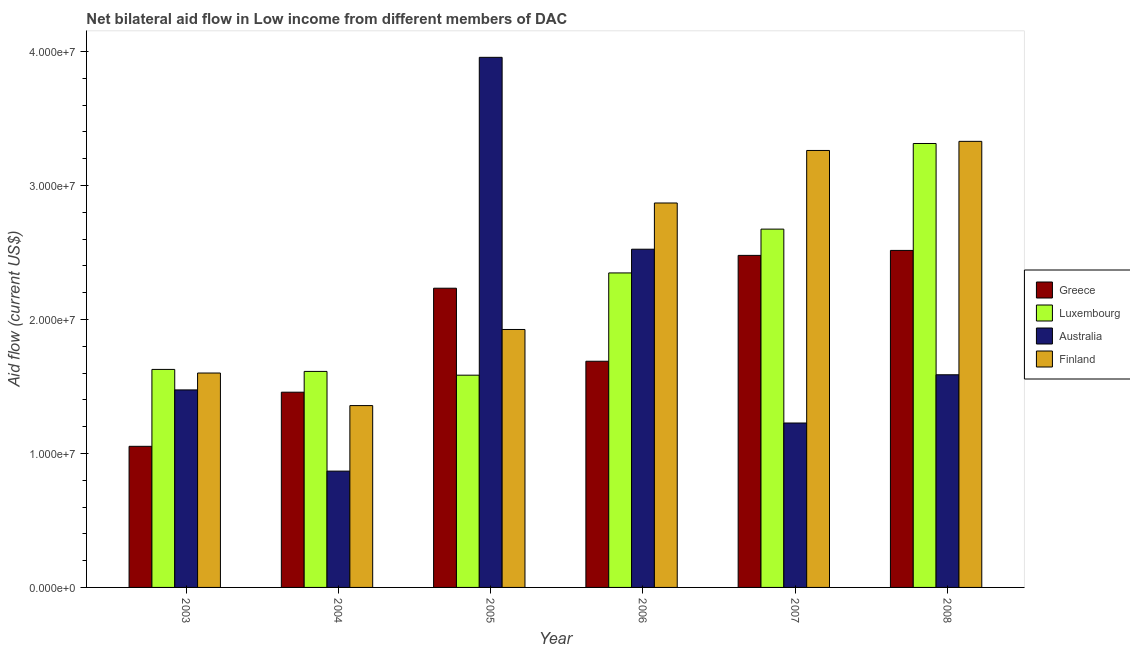How many different coloured bars are there?
Ensure brevity in your answer.  4. Are the number of bars on each tick of the X-axis equal?
Your answer should be compact. Yes. How many bars are there on the 6th tick from the right?
Your response must be concise. 4. What is the label of the 5th group of bars from the left?
Provide a succinct answer. 2007. What is the amount of aid given by finland in 2005?
Provide a short and direct response. 1.92e+07. Across all years, what is the maximum amount of aid given by australia?
Your response must be concise. 3.96e+07. Across all years, what is the minimum amount of aid given by australia?
Offer a very short reply. 8.68e+06. What is the total amount of aid given by greece in the graph?
Ensure brevity in your answer.  1.14e+08. What is the difference between the amount of aid given by greece in 2006 and that in 2008?
Ensure brevity in your answer.  -8.27e+06. What is the difference between the amount of aid given by finland in 2005 and the amount of aid given by greece in 2006?
Offer a terse response. -9.44e+06. What is the average amount of aid given by finland per year?
Provide a short and direct response. 2.39e+07. In the year 2006, what is the difference between the amount of aid given by greece and amount of aid given by luxembourg?
Provide a short and direct response. 0. In how many years, is the amount of aid given by finland greater than 16000000 US$?
Offer a terse response. 4. What is the ratio of the amount of aid given by greece in 2005 to that in 2008?
Keep it short and to the point. 0.89. Is the amount of aid given by greece in 2004 less than that in 2008?
Give a very brief answer. Yes. What is the difference between the highest and the second highest amount of aid given by australia?
Keep it short and to the point. 1.43e+07. What is the difference between the highest and the lowest amount of aid given by finland?
Your answer should be very brief. 1.97e+07. Is it the case that in every year, the sum of the amount of aid given by finland and amount of aid given by greece is greater than the sum of amount of aid given by luxembourg and amount of aid given by australia?
Make the answer very short. No. What does the 2nd bar from the left in 2005 represents?
Make the answer very short. Luxembourg. What does the 2nd bar from the right in 2006 represents?
Keep it short and to the point. Australia. Are all the bars in the graph horizontal?
Provide a short and direct response. No. Are the values on the major ticks of Y-axis written in scientific E-notation?
Ensure brevity in your answer.  Yes. Where does the legend appear in the graph?
Keep it short and to the point. Center right. How many legend labels are there?
Give a very brief answer. 4. What is the title of the graph?
Offer a terse response. Net bilateral aid flow in Low income from different members of DAC. What is the label or title of the X-axis?
Keep it short and to the point. Year. What is the label or title of the Y-axis?
Provide a short and direct response. Aid flow (current US$). What is the Aid flow (current US$) of Greece in 2003?
Keep it short and to the point. 1.05e+07. What is the Aid flow (current US$) of Luxembourg in 2003?
Provide a succinct answer. 1.63e+07. What is the Aid flow (current US$) in Australia in 2003?
Offer a terse response. 1.47e+07. What is the Aid flow (current US$) in Finland in 2003?
Make the answer very short. 1.60e+07. What is the Aid flow (current US$) in Greece in 2004?
Offer a terse response. 1.46e+07. What is the Aid flow (current US$) of Luxembourg in 2004?
Offer a very short reply. 1.61e+07. What is the Aid flow (current US$) in Australia in 2004?
Your response must be concise. 8.68e+06. What is the Aid flow (current US$) of Finland in 2004?
Provide a succinct answer. 1.36e+07. What is the Aid flow (current US$) of Greece in 2005?
Your answer should be very brief. 2.23e+07. What is the Aid flow (current US$) in Luxembourg in 2005?
Your answer should be compact. 1.58e+07. What is the Aid flow (current US$) in Australia in 2005?
Provide a succinct answer. 3.96e+07. What is the Aid flow (current US$) of Finland in 2005?
Give a very brief answer. 1.92e+07. What is the Aid flow (current US$) of Greece in 2006?
Your answer should be compact. 1.69e+07. What is the Aid flow (current US$) in Luxembourg in 2006?
Your answer should be very brief. 2.35e+07. What is the Aid flow (current US$) in Australia in 2006?
Provide a short and direct response. 2.52e+07. What is the Aid flow (current US$) of Finland in 2006?
Offer a terse response. 2.87e+07. What is the Aid flow (current US$) in Greece in 2007?
Ensure brevity in your answer.  2.48e+07. What is the Aid flow (current US$) in Luxembourg in 2007?
Give a very brief answer. 2.67e+07. What is the Aid flow (current US$) in Australia in 2007?
Make the answer very short. 1.23e+07. What is the Aid flow (current US$) in Finland in 2007?
Your answer should be very brief. 3.26e+07. What is the Aid flow (current US$) of Greece in 2008?
Offer a very short reply. 2.52e+07. What is the Aid flow (current US$) in Luxembourg in 2008?
Your answer should be compact. 3.31e+07. What is the Aid flow (current US$) of Australia in 2008?
Offer a terse response. 1.59e+07. What is the Aid flow (current US$) in Finland in 2008?
Offer a terse response. 3.33e+07. Across all years, what is the maximum Aid flow (current US$) of Greece?
Your response must be concise. 2.52e+07. Across all years, what is the maximum Aid flow (current US$) of Luxembourg?
Provide a succinct answer. 3.31e+07. Across all years, what is the maximum Aid flow (current US$) in Australia?
Provide a succinct answer. 3.96e+07. Across all years, what is the maximum Aid flow (current US$) of Finland?
Give a very brief answer. 3.33e+07. Across all years, what is the minimum Aid flow (current US$) of Greece?
Your answer should be very brief. 1.05e+07. Across all years, what is the minimum Aid flow (current US$) of Luxembourg?
Give a very brief answer. 1.58e+07. Across all years, what is the minimum Aid flow (current US$) of Australia?
Offer a terse response. 8.68e+06. Across all years, what is the minimum Aid flow (current US$) of Finland?
Keep it short and to the point. 1.36e+07. What is the total Aid flow (current US$) in Greece in the graph?
Provide a succinct answer. 1.14e+08. What is the total Aid flow (current US$) in Luxembourg in the graph?
Your response must be concise. 1.32e+08. What is the total Aid flow (current US$) in Australia in the graph?
Offer a very short reply. 1.16e+08. What is the total Aid flow (current US$) of Finland in the graph?
Your answer should be very brief. 1.43e+08. What is the difference between the Aid flow (current US$) of Greece in 2003 and that in 2004?
Provide a short and direct response. -4.04e+06. What is the difference between the Aid flow (current US$) in Australia in 2003 and that in 2004?
Ensure brevity in your answer.  6.06e+06. What is the difference between the Aid flow (current US$) of Finland in 2003 and that in 2004?
Provide a succinct answer. 2.43e+06. What is the difference between the Aid flow (current US$) of Greece in 2003 and that in 2005?
Provide a short and direct response. -1.18e+07. What is the difference between the Aid flow (current US$) in Luxembourg in 2003 and that in 2005?
Your answer should be compact. 4.30e+05. What is the difference between the Aid flow (current US$) of Australia in 2003 and that in 2005?
Your response must be concise. -2.48e+07. What is the difference between the Aid flow (current US$) of Finland in 2003 and that in 2005?
Offer a terse response. -3.25e+06. What is the difference between the Aid flow (current US$) of Greece in 2003 and that in 2006?
Offer a very short reply. -6.35e+06. What is the difference between the Aid flow (current US$) of Luxembourg in 2003 and that in 2006?
Keep it short and to the point. -7.20e+06. What is the difference between the Aid flow (current US$) of Australia in 2003 and that in 2006?
Keep it short and to the point. -1.05e+07. What is the difference between the Aid flow (current US$) of Finland in 2003 and that in 2006?
Ensure brevity in your answer.  -1.27e+07. What is the difference between the Aid flow (current US$) in Greece in 2003 and that in 2007?
Keep it short and to the point. -1.42e+07. What is the difference between the Aid flow (current US$) in Luxembourg in 2003 and that in 2007?
Make the answer very short. -1.05e+07. What is the difference between the Aid flow (current US$) in Australia in 2003 and that in 2007?
Make the answer very short. 2.47e+06. What is the difference between the Aid flow (current US$) of Finland in 2003 and that in 2007?
Your answer should be compact. -1.66e+07. What is the difference between the Aid flow (current US$) in Greece in 2003 and that in 2008?
Provide a short and direct response. -1.46e+07. What is the difference between the Aid flow (current US$) in Luxembourg in 2003 and that in 2008?
Give a very brief answer. -1.69e+07. What is the difference between the Aid flow (current US$) in Australia in 2003 and that in 2008?
Give a very brief answer. -1.13e+06. What is the difference between the Aid flow (current US$) in Finland in 2003 and that in 2008?
Provide a short and direct response. -1.73e+07. What is the difference between the Aid flow (current US$) in Greece in 2004 and that in 2005?
Your response must be concise. -7.76e+06. What is the difference between the Aid flow (current US$) of Australia in 2004 and that in 2005?
Provide a succinct answer. -3.09e+07. What is the difference between the Aid flow (current US$) of Finland in 2004 and that in 2005?
Make the answer very short. -5.68e+06. What is the difference between the Aid flow (current US$) in Greece in 2004 and that in 2006?
Keep it short and to the point. -2.31e+06. What is the difference between the Aid flow (current US$) of Luxembourg in 2004 and that in 2006?
Your response must be concise. -7.35e+06. What is the difference between the Aid flow (current US$) in Australia in 2004 and that in 2006?
Ensure brevity in your answer.  -1.66e+07. What is the difference between the Aid flow (current US$) of Finland in 2004 and that in 2006?
Your answer should be compact. -1.51e+07. What is the difference between the Aid flow (current US$) in Greece in 2004 and that in 2007?
Provide a succinct answer. -1.02e+07. What is the difference between the Aid flow (current US$) in Luxembourg in 2004 and that in 2007?
Give a very brief answer. -1.06e+07. What is the difference between the Aid flow (current US$) of Australia in 2004 and that in 2007?
Keep it short and to the point. -3.59e+06. What is the difference between the Aid flow (current US$) in Finland in 2004 and that in 2007?
Ensure brevity in your answer.  -1.90e+07. What is the difference between the Aid flow (current US$) in Greece in 2004 and that in 2008?
Provide a short and direct response. -1.06e+07. What is the difference between the Aid flow (current US$) in Luxembourg in 2004 and that in 2008?
Provide a succinct answer. -1.70e+07. What is the difference between the Aid flow (current US$) of Australia in 2004 and that in 2008?
Ensure brevity in your answer.  -7.19e+06. What is the difference between the Aid flow (current US$) in Finland in 2004 and that in 2008?
Offer a terse response. -1.97e+07. What is the difference between the Aid flow (current US$) in Greece in 2005 and that in 2006?
Keep it short and to the point. 5.45e+06. What is the difference between the Aid flow (current US$) of Luxembourg in 2005 and that in 2006?
Your answer should be very brief. -7.63e+06. What is the difference between the Aid flow (current US$) in Australia in 2005 and that in 2006?
Ensure brevity in your answer.  1.43e+07. What is the difference between the Aid flow (current US$) of Finland in 2005 and that in 2006?
Keep it short and to the point. -9.44e+06. What is the difference between the Aid flow (current US$) in Greece in 2005 and that in 2007?
Your answer should be compact. -2.45e+06. What is the difference between the Aid flow (current US$) of Luxembourg in 2005 and that in 2007?
Provide a short and direct response. -1.09e+07. What is the difference between the Aid flow (current US$) of Australia in 2005 and that in 2007?
Your answer should be compact. 2.73e+07. What is the difference between the Aid flow (current US$) in Finland in 2005 and that in 2007?
Your response must be concise. -1.34e+07. What is the difference between the Aid flow (current US$) in Greece in 2005 and that in 2008?
Your answer should be compact. -2.82e+06. What is the difference between the Aid flow (current US$) of Luxembourg in 2005 and that in 2008?
Offer a terse response. -1.73e+07. What is the difference between the Aid flow (current US$) in Australia in 2005 and that in 2008?
Keep it short and to the point. 2.37e+07. What is the difference between the Aid flow (current US$) in Finland in 2005 and that in 2008?
Keep it short and to the point. -1.40e+07. What is the difference between the Aid flow (current US$) in Greece in 2006 and that in 2007?
Provide a short and direct response. -7.90e+06. What is the difference between the Aid flow (current US$) of Luxembourg in 2006 and that in 2007?
Provide a short and direct response. -3.27e+06. What is the difference between the Aid flow (current US$) in Australia in 2006 and that in 2007?
Provide a succinct answer. 1.30e+07. What is the difference between the Aid flow (current US$) of Finland in 2006 and that in 2007?
Offer a terse response. -3.92e+06. What is the difference between the Aid flow (current US$) of Greece in 2006 and that in 2008?
Your answer should be very brief. -8.27e+06. What is the difference between the Aid flow (current US$) in Luxembourg in 2006 and that in 2008?
Your answer should be compact. -9.66e+06. What is the difference between the Aid flow (current US$) in Australia in 2006 and that in 2008?
Your response must be concise. 9.37e+06. What is the difference between the Aid flow (current US$) in Finland in 2006 and that in 2008?
Your answer should be compact. -4.60e+06. What is the difference between the Aid flow (current US$) of Greece in 2007 and that in 2008?
Provide a succinct answer. -3.70e+05. What is the difference between the Aid flow (current US$) of Luxembourg in 2007 and that in 2008?
Give a very brief answer. -6.39e+06. What is the difference between the Aid flow (current US$) of Australia in 2007 and that in 2008?
Keep it short and to the point. -3.60e+06. What is the difference between the Aid flow (current US$) in Finland in 2007 and that in 2008?
Your answer should be very brief. -6.80e+05. What is the difference between the Aid flow (current US$) of Greece in 2003 and the Aid flow (current US$) of Luxembourg in 2004?
Your answer should be very brief. -5.59e+06. What is the difference between the Aid flow (current US$) in Greece in 2003 and the Aid flow (current US$) in Australia in 2004?
Make the answer very short. 1.85e+06. What is the difference between the Aid flow (current US$) in Greece in 2003 and the Aid flow (current US$) in Finland in 2004?
Give a very brief answer. -3.04e+06. What is the difference between the Aid flow (current US$) of Luxembourg in 2003 and the Aid flow (current US$) of Australia in 2004?
Make the answer very short. 7.59e+06. What is the difference between the Aid flow (current US$) in Luxembourg in 2003 and the Aid flow (current US$) in Finland in 2004?
Provide a short and direct response. 2.70e+06. What is the difference between the Aid flow (current US$) in Australia in 2003 and the Aid flow (current US$) in Finland in 2004?
Offer a very short reply. 1.17e+06. What is the difference between the Aid flow (current US$) in Greece in 2003 and the Aid flow (current US$) in Luxembourg in 2005?
Offer a very short reply. -5.31e+06. What is the difference between the Aid flow (current US$) of Greece in 2003 and the Aid flow (current US$) of Australia in 2005?
Give a very brief answer. -2.90e+07. What is the difference between the Aid flow (current US$) of Greece in 2003 and the Aid flow (current US$) of Finland in 2005?
Your answer should be very brief. -8.72e+06. What is the difference between the Aid flow (current US$) in Luxembourg in 2003 and the Aid flow (current US$) in Australia in 2005?
Your response must be concise. -2.33e+07. What is the difference between the Aid flow (current US$) of Luxembourg in 2003 and the Aid flow (current US$) of Finland in 2005?
Give a very brief answer. -2.98e+06. What is the difference between the Aid flow (current US$) of Australia in 2003 and the Aid flow (current US$) of Finland in 2005?
Offer a very short reply. -4.51e+06. What is the difference between the Aid flow (current US$) in Greece in 2003 and the Aid flow (current US$) in Luxembourg in 2006?
Offer a terse response. -1.29e+07. What is the difference between the Aid flow (current US$) of Greece in 2003 and the Aid flow (current US$) of Australia in 2006?
Provide a short and direct response. -1.47e+07. What is the difference between the Aid flow (current US$) of Greece in 2003 and the Aid flow (current US$) of Finland in 2006?
Your response must be concise. -1.82e+07. What is the difference between the Aid flow (current US$) of Luxembourg in 2003 and the Aid flow (current US$) of Australia in 2006?
Keep it short and to the point. -8.97e+06. What is the difference between the Aid flow (current US$) in Luxembourg in 2003 and the Aid flow (current US$) in Finland in 2006?
Your answer should be compact. -1.24e+07. What is the difference between the Aid flow (current US$) of Australia in 2003 and the Aid flow (current US$) of Finland in 2006?
Provide a short and direct response. -1.40e+07. What is the difference between the Aid flow (current US$) in Greece in 2003 and the Aid flow (current US$) in Luxembourg in 2007?
Provide a succinct answer. -1.62e+07. What is the difference between the Aid flow (current US$) of Greece in 2003 and the Aid flow (current US$) of Australia in 2007?
Offer a terse response. -1.74e+06. What is the difference between the Aid flow (current US$) in Greece in 2003 and the Aid flow (current US$) in Finland in 2007?
Keep it short and to the point. -2.21e+07. What is the difference between the Aid flow (current US$) in Luxembourg in 2003 and the Aid flow (current US$) in Australia in 2007?
Keep it short and to the point. 4.00e+06. What is the difference between the Aid flow (current US$) in Luxembourg in 2003 and the Aid flow (current US$) in Finland in 2007?
Make the answer very short. -1.63e+07. What is the difference between the Aid flow (current US$) in Australia in 2003 and the Aid flow (current US$) in Finland in 2007?
Offer a very short reply. -1.79e+07. What is the difference between the Aid flow (current US$) in Greece in 2003 and the Aid flow (current US$) in Luxembourg in 2008?
Keep it short and to the point. -2.26e+07. What is the difference between the Aid flow (current US$) of Greece in 2003 and the Aid flow (current US$) of Australia in 2008?
Make the answer very short. -5.34e+06. What is the difference between the Aid flow (current US$) in Greece in 2003 and the Aid flow (current US$) in Finland in 2008?
Your answer should be compact. -2.28e+07. What is the difference between the Aid flow (current US$) in Luxembourg in 2003 and the Aid flow (current US$) in Finland in 2008?
Offer a terse response. -1.70e+07. What is the difference between the Aid flow (current US$) of Australia in 2003 and the Aid flow (current US$) of Finland in 2008?
Your answer should be compact. -1.86e+07. What is the difference between the Aid flow (current US$) of Greece in 2004 and the Aid flow (current US$) of Luxembourg in 2005?
Your answer should be very brief. -1.27e+06. What is the difference between the Aid flow (current US$) in Greece in 2004 and the Aid flow (current US$) in Australia in 2005?
Make the answer very short. -2.50e+07. What is the difference between the Aid flow (current US$) of Greece in 2004 and the Aid flow (current US$) of Finland in 2005?
Provide a succinct answer. -4.68e+06. What is the difference between the Aid flow (current US$) in Luxembourg in 2004 and the Aid flow (current US$) in Australia in 2005?
Ensure brevity in your answer.  -2.34e+07. What is the difference between the Aid flow (current US$) in Luxembourg in 2004 and the Aid flow (current US$) in Finland in 2005?
Offer a terse response. -3.13e+06. What is the difference between the Aid flow (current US$) in Australia in 2004 and the Aid flow (current US$) in Finland in 2005?
Provide a succinct answer. -1.06e+07. What is the difference between the Aid flow (current US$) in Greece in 2004 and the Aid flow (current US$) in Luxembourg in 2006?
Your answer should be compact. -8.90e+06. What is the difference between the Aid flow (current US$) of Greece in 2004 and the Aid flow (current US$) of Australia in 2006?
Make the answer very short. -1.07e+07. What is the difference between the Aid flow (current US$) of Greece in 2004 and the Aid flow (current US$) of Finland in 2006?
Your answer should be very brief. -1.41e+07. What is the difference between the Aid flow (current US$) of Luxembourg in 2004 and the Aid flow (current US$) of Australia in 2006?
Provide a short and direct response. -9.12e+06. What is the difference between the Aid flow (current US$) in Luxembourg in 2004 and the Aid flow (current US$) in Finland in 2006?
Make the answer very short. -1.26e+07. What is the difference between the Aid flow (current US$) in Australia in 2004 and the Aid flow (current US$) in Finland in 2006?
Your answer should be very brief. -2.00e+07. What is the difference between the Aid flow (current US$) of Greece in 2004 and the Aid flow (current US$) of Luxembourg in 2007?
Offer a terse response. -1.22e+07. What is the difference between the Aid flow (current US$) of Greece in 2004 and the Aid flow (current US$) of Australia in 2007?
Provide a short and direct response. 2.30e+06. What is the difference between the Aid flow (current US$) of Greece in 2004 and the Aid flow (current US$) of Finland in 2007?
Your response must be concise. -1.80e+07. What is the difference between the Aid flow (current US$) in Luxembourg in 2004 and the Aid flow (current US$) in Australia in 2007?
Offer a terse response. 3.85e+06. What is the difference between the Aid flow (current US$) of Luxembourg in 2004 and the Aid flow (current US$) of Finland in 2007?
Give a very brief answer. -1.65e+07. What is the difference between the Aid flow (current US$) in Australia in 2004 and the Aid flow (current US$) in Finland in 2007?
Your response must be concise. -2.39e+07. What is the difference between the Aid flow (current US$) in Greece in 2004 and the Aid flow (current US$) in Luxembourg in 2008?
Offer a very short reply. -1.86e+07. What is the difference between the Aid flow (current US$) in Greece in 2004 and the Aid flow (current US$) in Australia in 2008?
Your answer should be very brief. -1.30e+06. What is the difference between the Aid flow (current US$) of Greece in 2004 and the Aid flow (current US$) of Finland in 2008?
Your response must be concise. -1.87e+07. What is the difference between the Aid flow (current US$) in Luxembourg in 2004 and the Aid flow (current US$) in Australia in 2008?
Give a very brief answer. 2.50e+05. What is the difference between the Aid flow (current US$) of Luxembourg in 2004 and the Aid flow (current US$) of Finland in 2008?
Provide a succinct answer. -1.72e+07. What is the difference between the Aid flow (current US$) in Australia in 2004 and the Aid flow (current US$) in Finland in 2008?
Make the answer very short. -2.46e+07. What is the difference between the Aid flow (current US$) in Greece in 2005 and the Aid flow (current US$) in Luxembourg in 2006?
Make the answer very short. -1.14e+06. What is the difference between the Aid flow (current US$) in Greece in 2005 and the Aid flow (current US$) in Australia in 2006?
Offer a very short reply. -2.91e+06. What is the difference between the Aid flow (current US$) in Greece in 2005 and the Aid flow (current US$) in Finland in 2006?
Make the answer very short. -6.36e+06. What is the difference between the Aid flow (current US$) of Luxembourg in 2005 and the Aid flow (current US$) of Australia in 2006?
Give a very brief answer. -9.40e+06. What is the difference between the Aid flow (current US$) of Luxembourg in 2005 and the Aid flow (current US$) of Finland in 2006?
Ensure brevity in your answer.  -1.28e+07. What is the difference between the Aid flow (current US$) of Australia in 2005 and the Aid flow (current US$) of Finland in 2006?
Your answer should be compact. 1.09e+07. What is the difference between the Aid flow (current US$) of Greece in 2005 and the Aid flow (current US$) of Luxembourg in 2007?
Provide a short and direct response. -4.41e+06. What is the difference between the Aid flow (current US$) of Greece in 2005 and the Aid flow (current US$) of Australia in 2007?
Offer a terse response. 1.01e+07. What is the difference between the Aid flow (current US$) in Greece in 2005 and the Aid flow (current US$) in Finland in 2007?
Keep it short and to the point. -1.03e+07. What is the difference between the Aid flow (current US$) in Luxembourg in 2005 and the Aid flow (current US$) in Australia in 2007?
Your response must be concise. 3.57e+06. What is the difference between the Aid flow (current US$) of Luxembourg in 2005 and the Aid flow (current US$) of Finland in 2007?
Provide a succinct answer. -1.68e+07. What is the difference between the Aid flow (current US$) in Australia in 2005 and the Aid flow (current US$) in Finland in 2007?
Ensure brevity in your answer.  6.95e+06. What is the difference between the Aid flow (current US$) of Greece in 2005 and the Aid flow (current US$) of Luxembourg in 2008?
Keep it short and to the point. -1.08e+07. What is the difference between the Aid flow (current US$) of Greece in 2005 and the Aid flow (current US$) of Australia in 2008?
Ensure brevity in your answer.  6.46e+06. What is the difference between the Aid flow (current US$) in Greece in 2005 and the Aid flow (current US$) in Finland in 2008?
Your answer should be very brief. -1.10e+07. What is the difference between the Aid flow (current US$) of Luxembourg in 2005 and the Aid flow (current US$) of Finland in 2008?
Provide a succinct answer. -1.74e+07. What is the difference between the Aid flow (current US$) of Australia in 2005 and the Aid flow (current US$) of Finland in 2008?
Ensure brevity in your answer.  6.27e+06. What is the difference between the Aid flow (current US$) of Greece in 2006 and the Aid flow (current US$) of Luxembourg in 2007?
Offer a very short reply. -9.86e+06. What is the difference between the Aid flow (current US$) in Greece in 2006 and the Aid flow (current US$) in Australia in 2007?
Your answer should be compact. 4.61e+06. What is the difference between the Aid flow (current US$) of Greece in 2006 and the Aid flow (current US$) of Finland in 2007?
Your answer should be compact. -1.57e+07. What is the difference between the Aid flow (current US$) of Luxembourg in 2006 and the Aid flow (current US$) of Australia in 2007?
Ensure brevity in your answer.  1.12e+07. What is the difference between the Aid flow (current US$) of Luxembourg in 2006 and the Aid flow (current US$) of Finland in 2007?
Your answer should be compact. -9.14e+06. What is the difference between the Aid flow (current US$) in Australia in 2006 and the Aid flow (current US$) in Finland in 2007?
Ensure brevity in your answer.  -7.37e+06. What is the difference between the Aid flow (current US$) of Greece in 2006 and the Aid flow (current US$) of Luxembourg in 2008?
Offer a terse response. -1.62e+07. What is the difference between the Aid flow (current US$) in Greece in 2006 and the Aid flow (current US$) in Australia in 2008?
Provide a short and direct response. 1.01e+06. What is the difference between the Aid flow (current US$) in Greece in 2006 and the Aid flow (current US$) in Finland in 2008?
Offer a very short reply. -1.64e+07. What is the difference between the Aid flow (current US$) of Luxembourg in 2006 and the Aid flow (current US$) of Australia in 2008?
Provide a short and direct response. 7.60e+06. What is the difference between the Aid flow (current US$) in Luxembourg in 2006 and the Aid flow (current US$) in Finland in 2008?
Give a very brief answer. -9.82e+06. What is the difference between the Aid flow (current US$) in Australia in 2006 and the Aid flow (current US$) in Finland in 2008?
Make the answer very short. -8.05e+06. What is the difference between the Aid flow (current US$) of Greece in 2007 and the Aid flow (current US$) of Luxembourg in 2008?
Your response must be concise. -8.35e+06. What is the difference between the Aid flow (current US$) in Greece in 2007 and the Aid flow (current US$) in Australia in 2008?
Provide a succinct answer. 8.91e+06. What is the difference between the Aid flow (current US$) in Greece in 2007 and the Aid flow (current US$) in Finland in 2008?
Offer a terse response. -8.51e+06. What is the difference between the Aid flow (current US$) of Luxembourg in 2007 and the Aid flow (current US$) of Australia in 2008?
Your answer should be compact. 1.09e+07. What is the difference between the Aid flow (current US$) in Luxembourg in 2007 and the Aid flow (current US$) in Finland in 2008?
Make the answer very short. -6.55e+06. What is the difference between the Aid flow (current US$) in Australia in 2007 and the Aid flow (current US$) in Finland in 2008?
Ensure brevity in your answer.  -2.10e+07. What is the average Aid flow (current US$) of Greece per year?
Offer a very short reply. 1.90e+07. What is the average Aid flow (current US$) of Luxembourg per year?
Ensure brevity in your answer.  2.19e+07. What is the average Aid flow (current US$) of Australia per year?
Offer a terse response. 1.94e+07. What is the average Aid flow (current US$) in Finland per year?
Keep it short and to the point. 2.39e+07. In the year 2003, what is the difference between the Aid flow (current US$) in Greece and Aid flow (current US$) in Luxembourg?
Keep it short and to the point. -5.74e+06. In the year 2003, what is the difference between the Aid flow (current US$) of Greece and Aid flow (current US$) of Australia?
Offer a very short reply. -4.21e+06. In the year 2003, what is the difference between the Aid flow (current US$) of Greece and Aid flow (current US$) of Finland?
Provide a succinct answer. -5.47e+06. In the year 2003, what is the difference between the Aid flow (current US$) of Luxembourg and Aid flow (current US$) of Australia?
Your response must be concise. 1.53e+06. In the year 2003, what is the difference between the Aid flow (current US$) of Australia and Aid flow (current US$) of Finland?
Your response must be concise. -1.26e+06. In the year 2004, what is the difference between the Aid flow (current US$) in Greece and Aid flow (current US$) in Luxembourg?
Make the answer very short. -1.55e+06. In the year 2004, what is the difference between the Aid flow (current US$) of Greece and Aid flow (current US$) of Australia?
Provide a succinct answer. 5.89e+06. In the year 2004, what is the difference between the Aid flow (current US$) of Luxembourg and Aid flow (current US$) of Australia?
Give a very brief answer. 7.44e+06. In the year 2004, what is the difference between the Aid flow (current US$) of Luxembourg and Aid flow (current US$) of Finland?
Provide a short and direct response. 2.55e+06. In the year 2004, what is the difference between the Aid flow (current US$) in Australia and Aid flow (current US$) in Finland?
Your response must be concise. -4.89e+06. In the year 2005, what is the difference between the Aid flow (current US$) in Greece and Aid flow (current US$) in Luxembourg?
Ensure brevity in your answer.  6.49e+06. In the year 2005, what is the difference between the Aid flow (current US$) of Greece and Aid flow (current US$) of Australia?
Your answer should be very brief. -1.72e+07. In the year 2005, what is the difference between the Aid flow (current US$) in Greece and Aid flow (current US$) in Finland?
Provide a short and direct response. 3.08e+06. In the year 2005, what is the difference between the Aid flow (current US$) of Luxembourg and Aid flow (current US$) of Australia?
Keep it short and to the point. -2.37e+07. In the year 2005, what is the difference between the Aid flow (current US$) of Luxembourg and Aid flow (current US$) of Finland?
Provide a short and direct response. -3.41e+06. In the year 2005, what is the difference between the Aid flow (current US$) in Australia and Aid flow (current US$) in Finland?
Make the answer very short. 2.03e+07. In the year 2006, what is the difference between the Aid flow (current US$) of Greece and Aid flow (current US$) of Luxembourg?
Keep it short and to the point. -6.59e+06. In the year 2006, what is the difference between the Aid flow (current US$) of Greece and Aid flow (current US$) of Australia?
Offer a terse response. -8.36e+06. In the year 2006, what is the difference between the Aid flow (current US$) in Greece and Aid flow (current US$) in Finland?
Keep it short and to the point. -1.18e+07. In the year 2006, what is the difference between the Aid flow (current US$) in Luxembourg and Aid flow (current US$) in Australia?
Keep it short and to the point. -1.77e+06. In the year 2006, what is the difference between the Aid flow (current US$) of Luxembourg and Aid flow (current US$) of Finland?
Ensure brevity in your answer.  -5.22e+06. In the year 2006, what is the difference between the Aid flow (current US$) of Australia and Aid flow (current US$) of Finland?
Your response must be concise. -3.45e+06. In the year 2007, what is the difference between the Aid flow (current US$) of Greece and Aid flow (current US$) of Luxembourg?
Your answer should be compact. -1.96e+06. In the year 2007, what is the difference between the Aid flow (current US$) of Greece and Aid flow (current US$) of Australia?
Offer a very short reply. 1.25e+07. In the year 2007, what is the difference between the Aid flow (current US$) in Greece and Aid flow (current US$) in Finland?
Provide a succinct answer. -7.83e+06. In the year 2007, what is the difference between the Aid flow (current US$) of Luxembourg and Aid flow (current US$) of Australia?
Your response must be concise. 1.45e+07. In the year 2007, what is the difference between the Aid flow (current US$) in Luxembourg and Aid flow (current US$) in Finland?
Your answer should be compact. -5.87e+06. In the year 2007, what is the difference between the Aid flow (current US$) in Australia and Aid flow (current US$) in Finland?
Your answer should be very brief. -2.03e+07. In the year 2008, what is the difference between the Aid flow (current US$) of Greece and Aid flow (current US$) of Luxembourg?
Make the answer very short. -7.98e+06. In the year 2008, what is the difference between the Aid flow (current US$) in Greece and Aid flow (current US$) in Australia?
Provide a succinct answer. 9.28e+06. In the year 2008, what is the difference between the Aid flow (current US$) of Greece and Aid flow (current US$) of Finland?
Keep it short and to the point. -8.14e+06. In the year 2008, what is the difference between the Aid flow (current US$) of Luxembourg and Aid flow (current US$) of Australia?
Provide a short and direct response. 1.73e+07. In the year 2008, what is the difference between the Aid flow (current US$) of Australia and Aid flow (current US$) of Finland?
Keep it short and to the point. -1.74e+07. What is the ratio of the Aid flow (current US$) in Greece in 2003 to that in 2004?
Your answer should be compact. 0.72. What is the ratio of the Aid flow (current US$) of Luxembourg in 2003 to that in 2004?
Provide a succinct answer. 1.01. What is the ratio of the Aid flow (current US$) of Australia in 2003 to that in 2004?
Your answer should be very brief. 1.7. What is the ratio of the Aid flow (current US$) in Finland in 2003 to that in 2004?
Your answer should be compact. 1.18. What is the ratio of the Aid flow (current US$) in Greece in 2003 to that in 2005?
Keep it short and to the point. 0.47. What is the ratio of the Aid flow (current US$) of Luxembourg in 2003 to that in 2005?
Keep it short and to the point. 1.03. What is the ratio of the Aid flow (current US$) of Australia in 2003 to that in 2005?
Your response must be concise. 0.37. What is the ratio of the Aid flow (current US$) in Finland in 2003 to that in 2005?
Ensure brevity in your answer.  0.83. What is the ratio of the Aid flow (current US$) in Greece in 2003 to that in 2006?
Ensure brevity in your answer.  0.62. What is the ratio of the Aid flow (current US$) in Luxembourg in 2003 to that in 2006?
Your response must be concise. 0.69. What is the ratio of the Aid flow (current US$) of Australia in 2003 to that in 2006?
Keep it short and to the point. 0.58. What is the ratio of the Aid flow (current US$) of Finland in 2003 to that in 2006?
Offer a terse response. 0.56. What is the ratio of the Aid flow (current US$) in Greece in 2003 to that in 2007?
Provide a short and direct response. 0.42. What is the ratio of the Aid flow (current US$) of Luxembourg in 2003 to that in 2007?
Make the answer very short. 0.61. What is the ratio of the Aid flow (current US$) in Australia in 2003 to that in 2007?
Your response must be concise. 1.2. What is the ratio of the Aid flow (current US$) of Finland in 2003 to that in 2007?
Your answer should be very brief. 0.49. What is the ratio of the Aid flow (current US$) in Greece in 2003 to that in 2008?
Give a very brief answer. 0.42. What is the ratio of the Aid flow (current US$) in Luxembourg in 2003 to that in 2008?
Make the answer very short. 0.49. What is the ratio of the Aid flow (current US$) of Australia in 2003 to that in 2008?
Offer a very short reply. 0.93. What is the ratio of the Aid flow (current US$) in Finland in 2003 to that in 2008?
Ensure brevity in your answer.  0.48. What is the ratio of the Aid flow (current US$) in Greece in 2004 to that in 2005?
Give a very brief answer. 0.65. What is the ratio of the Aid flow (current US$) in Luxembourg in 2004 to that in 2005?
Provide a succinct answer. 1.02. What is the ratio of the Aid flow (current US$) of Australia in 2004 to that in 2005?
Your answer should be very brief. 0.22. What is the ratio of the Aid flow (current US$) in Finland in 2004 to that in 2005?
Your response must be concise. 0.7. What is the ratio of the Aid flow (current US$) of Greece in 2004 to that in 2006?
Your response must be concise. 0.86. What is the ratio of the Aid flow (current US$) of Luxembourg in 2004 to that in 2006?
Offer a very short reply. 0.69. What is the ratio of the Aid flow (current US$) in Australia in 2004 to that in 2006?
Make the answer very short. 0.34. What is the ratio of the Aid flow (current US$) in Finland in 2004 to that in 2006?
Your answer should be compact. 0.47. What is the ratio of the Aid flow (current US$) in Greece in 2004 to that in 2007?
Keep it short and to the point. 0.59. What is the ratio of the Aid flow (current US$) of Luxembourg in 2004 to that in 2007?
Offer a very short reply. 0.6. What is the ratio of the Aid flow (current US$) in Australia in 2004 to that in 2007?
Offer a terse response. 0.71. What is the ratio of the Aid flow (current US$) in Finland in 2004 to that in 2007?
Your answer should be very brief. 0.42. What is the ratio of the Aid flow (current US$) in Greece in 2004 to that in 2008?
Provide a short and direct response. 0.58. What is the ratio of the Aid flow (current US$) of Luxembourg in 2004 to that in 2008?
Keep it short and to the point. 0.49. What is the ratio of the Aid flow (current US$) of Australia in 2004 to that in 2008?
Your answer should be very brief. 0.55. What is the ratio of the Aid flow (current US$) in Finland in 2004 to that in 2008?
Your response must be concise. 0.41. What is the ratio of the Aid flow (current US$) of Greece in 2005 to that in 2006?
Offer a terse response. 1.32. What is the ratio of the Aid flow (current US$) in Luxembourg in 2005 to that in 2006?
Provide a succinct answer. 0.67. What is the ratio of the Aid flow (current US$) of Australia in 2005 to that in 2006?
Provide a short and direct response. 1.57. What is the ratio of the Aid flow (current US$) in Finland in 2005 to that in 2006?
Give a very brief answer. 0.67. What is the ratio of the Aid flow (current US$) of Greece in 2005 to that in 2007?
Your answer should be very brief. 0.9. What is the ratio of the Aid flow (current US$) in Luxembourg in 2005 to that in 2007?
Keep it short and to the point. 0.59. What is the ratio of the Aid flow (current US$) of Australia in 2005 to that in 2007?
Keep it short and to the point. 3.22. What is the ratio of the Aid flow (current US$) in Finland in 2005 to that in 2007?
Offer a very short reply. 0.59. What is the ratio of the Aid flow (current US$) in Greece in 2005 to that in 2008?
Provide a short and direct response. 0.89. What is the ratio of the Aid flow (current US$) in Luxembourg in 2005 to that in 2008?
Offer a very short reply. 0.48. What is the ratio of the Aid flow (current US$) of Australia in 2005 to that in 2008?
Keep it short and to the point. 2.49. What is the ratio of the Aid flow (current US$) in Finland in 2005 to that in 2008?
Give a very brief answer. 0.58. What is the ratio of the Aid flow (current US$) in Greece in 2006 to that in 2007?
Provide a short and direct response. 0.68. What is the ratio of the Aid flow (current US$) of Luxembourg in 2006 to that in 2007?
Provide a succinct answer. 0.88. What is the ratio of the Aid flow (current US$) of Australia in 2006 to that in 2007?
Give a very brief answer. 2.06. What is the ratio of the Aid flow (current US$) in Finland in 2006 to that in 2007?
Offer a terse response. 0.88. What is the ratio of the Aid flow (current US$) in Greece in 2006 to that in 2008?
Make the answer very short. 0.67. What is the ratio of the Aid flow (current US$) of Luxembourg in 2006 to that in 2008?
Offer a terse response. 0.71. What is the ratio of the Aid flow (current US$) of Australia in 2006 to that in 2008?
Your answer should be very brief. 1.59. What is the ratio of the Aid flow (current US$) of Finland in 2006 to that in 2008?
Offer a terse response. 0.86. What is the ratio of the Aid flow (current US$) in Luxembourg in 2007 to that in 2008?
Ensure brevity in your answer.  0.81. What is the ratio of the Aid flow (current US$) of Australia in 2007 to that in 2008?
Provide a succinct answer. 0.77. What is the ratio of the Aid flow (current US$) of Finland in 2007 to that in 2008?
Offer a terse response. 0.98. What is the difference between the highest and the second highest Aid flow (current US$) of Greece?
Offer a terse response. 3.70e+05. What is the difference between the highest and the second highest Aid flow (current US$) in Luxembourg?
Your answer should be very brief. 6.39e+06. What is the difference between the highest and the second highest Aid flow (current US$) in Australia?
Offer a terse response. 1.43e+07. What is the difference between the highest and the second highest Aid flow (current US$) in Finland?
Your response must be concise. 6.80e+05. What is the difference between the highest and the lowest Aid flow (current US$) in Greece?
Give a very brief answer. 1.46e+07. What is the difference between the highest and the lowest Aid flow (current US$) in Luxembourg?
Make the answer very short. 1.73e+07. What is the difference between the highest and the lowest Aid flow (current US$) in Australia?
Keep it short and to the point. 3.09e+07. What is the difference between the highest and the lowest Aid flow (current US$) of Finland?
Provide a short and direct response. 1.97e+07. 